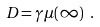<formula> <loc_0><loc_0><loc_500><loc_500>D = \gamma \mu ( \infty ) \ .</formula> 